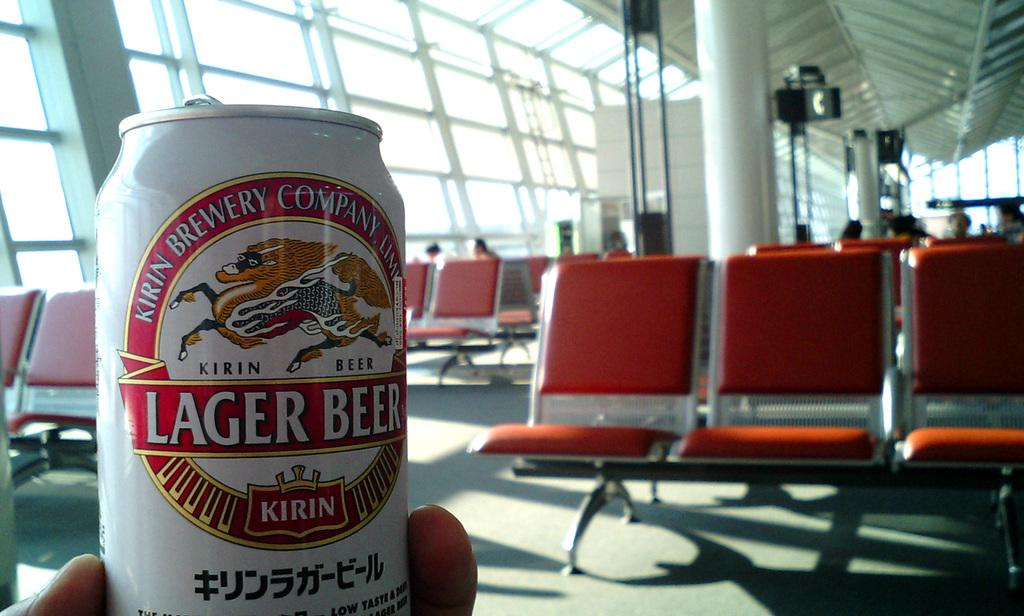<image>
Create a compact narrative representing the image presented. A hand holding a kirin brand brewing company beer. 